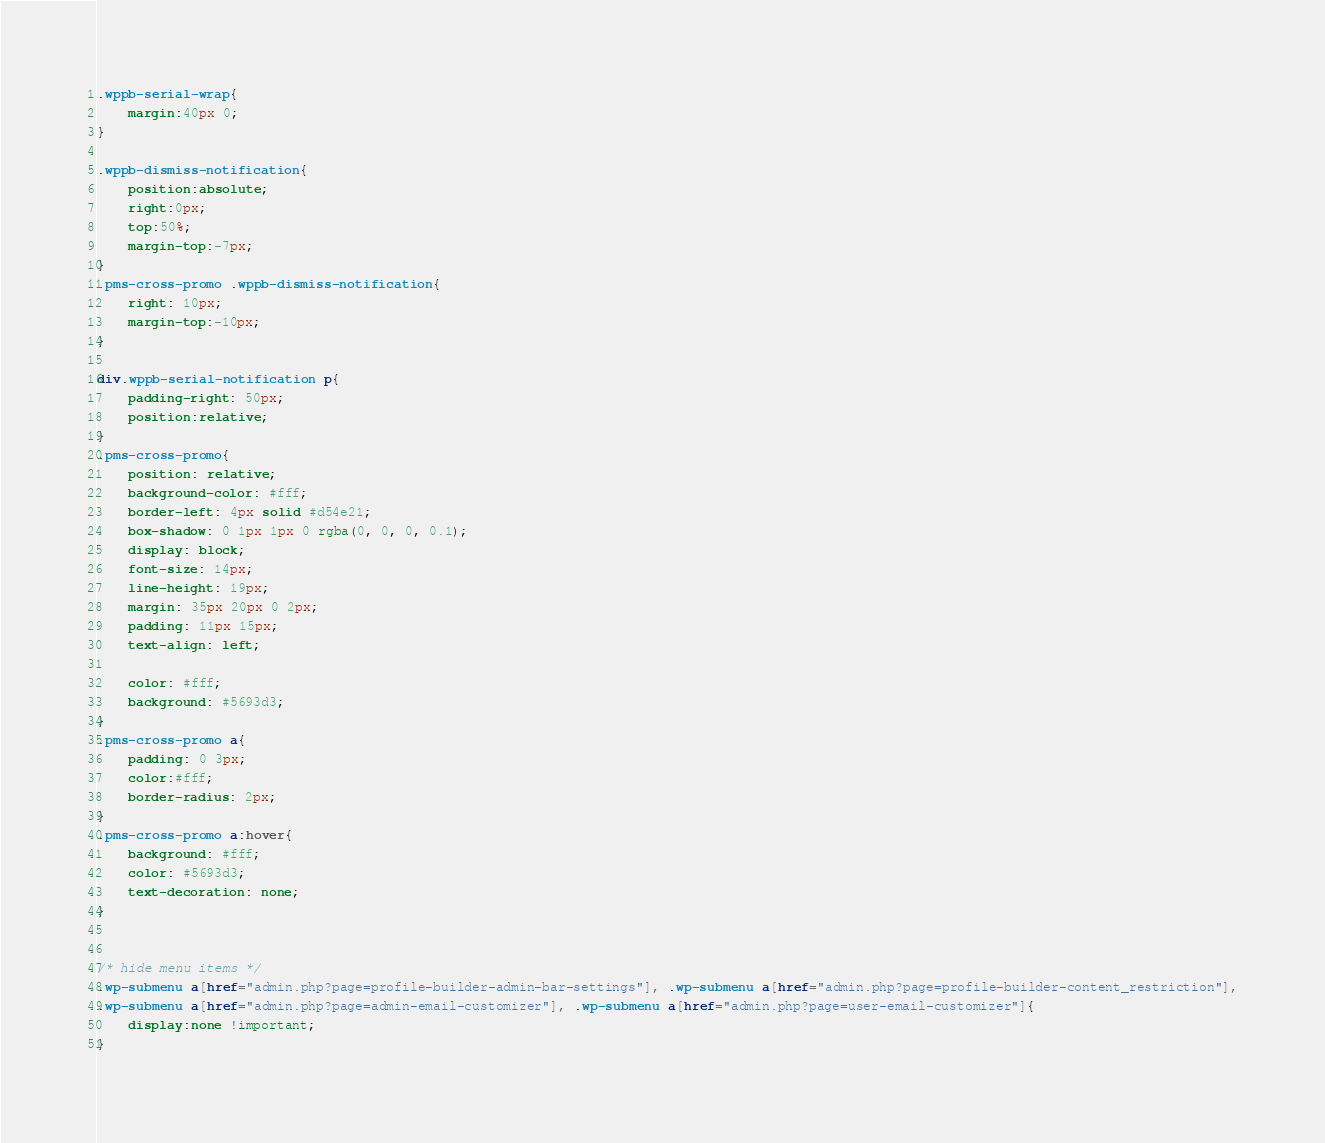<code> <loc_0><loc_0><loc_500><loc_500><_CSS_>.wppb-serial-wrap{
    margin:40px 0;
}

.wppb-dismiss-notification{
    position:absolute;
    right:0px;
    top:50%;
    margin-top:-7px;
}
.pms-cross-promo .wppb-dismiss-notification{
	right: 10px;
	margin-top:-10px;
}

div.wppb-serial-notification p{
    padding-right: 50px;
    position:relative;
}
.pms-cross-promo{
	position: relative;
	background-color: #fff;
	border-left: 4px solid #d54e21;
	box-shadow: 0 1px 1px 0 rgba(0, 0, 0, 0.1);
	display: block;
	font-size: 14px;
	line-height: 19px;
	margin: 35px 20px 0 2px;
	padding: 11px 15px;
	text-align: left;

	color: #fff;
	background: #5693d3;
}
.pms-cross-promo a{
	padding: 0 3px;
	color:#fff;
	border-radius: 2px;
}
.pms-cross-promo a:hover{
	background: #fff;
	color: #5693d3;
	text-decoration: none;
}


/* hide menu items */
.wp-submenu a[href="admin.php?page=profile-builder-admin-bar-settings"], .wp-submenu a[href="admin.php?page=profile-builder-content_restriction"],
.wp-submenu a[href="admin.php?page=admin-email-customizer"], .wp-submenu a[href="admin.php?page=user-email-customizer"]{
	display:none !important;
}</code> 